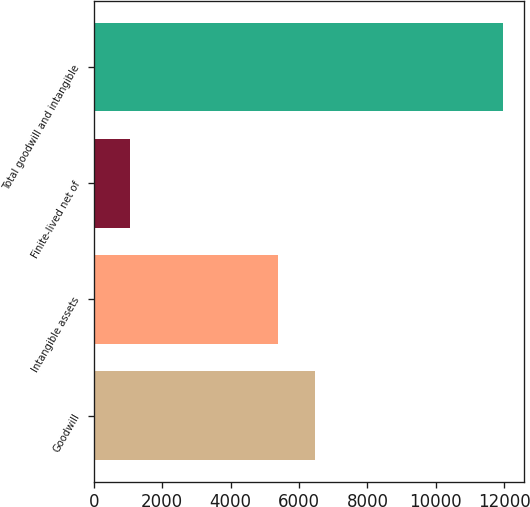<chart> <loc_0><loc_0><loc_500><loc_500><bar_chart><fcel>Goodwill<fcel>Intangible assets<fcel>Finite-lived net of<fcel>Total goodwill and intangible<nl><fcel>6469.1<fcel>5378<fcel>1063<fcel>11974<nl></chart> 